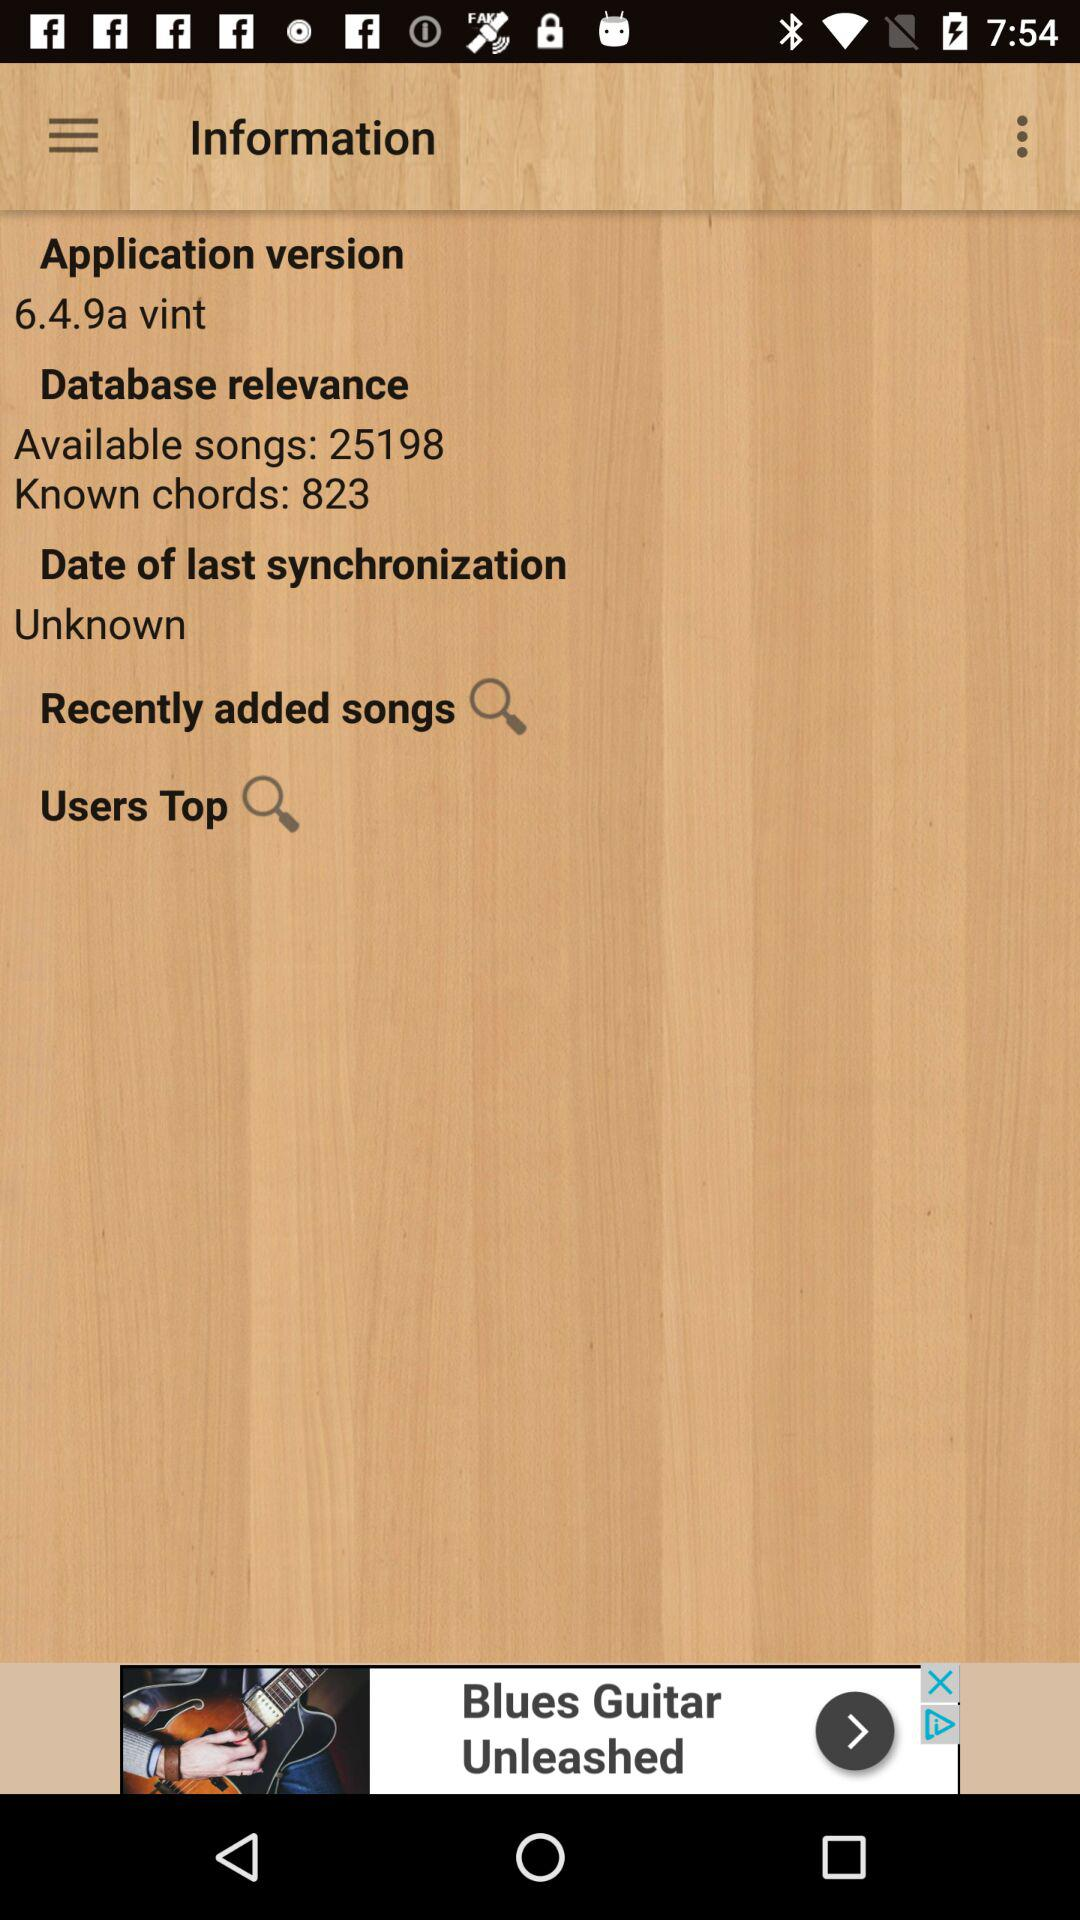Which song is the most recently added?
When the provided information is insufficient, respond with <no answer>. <no answer> 